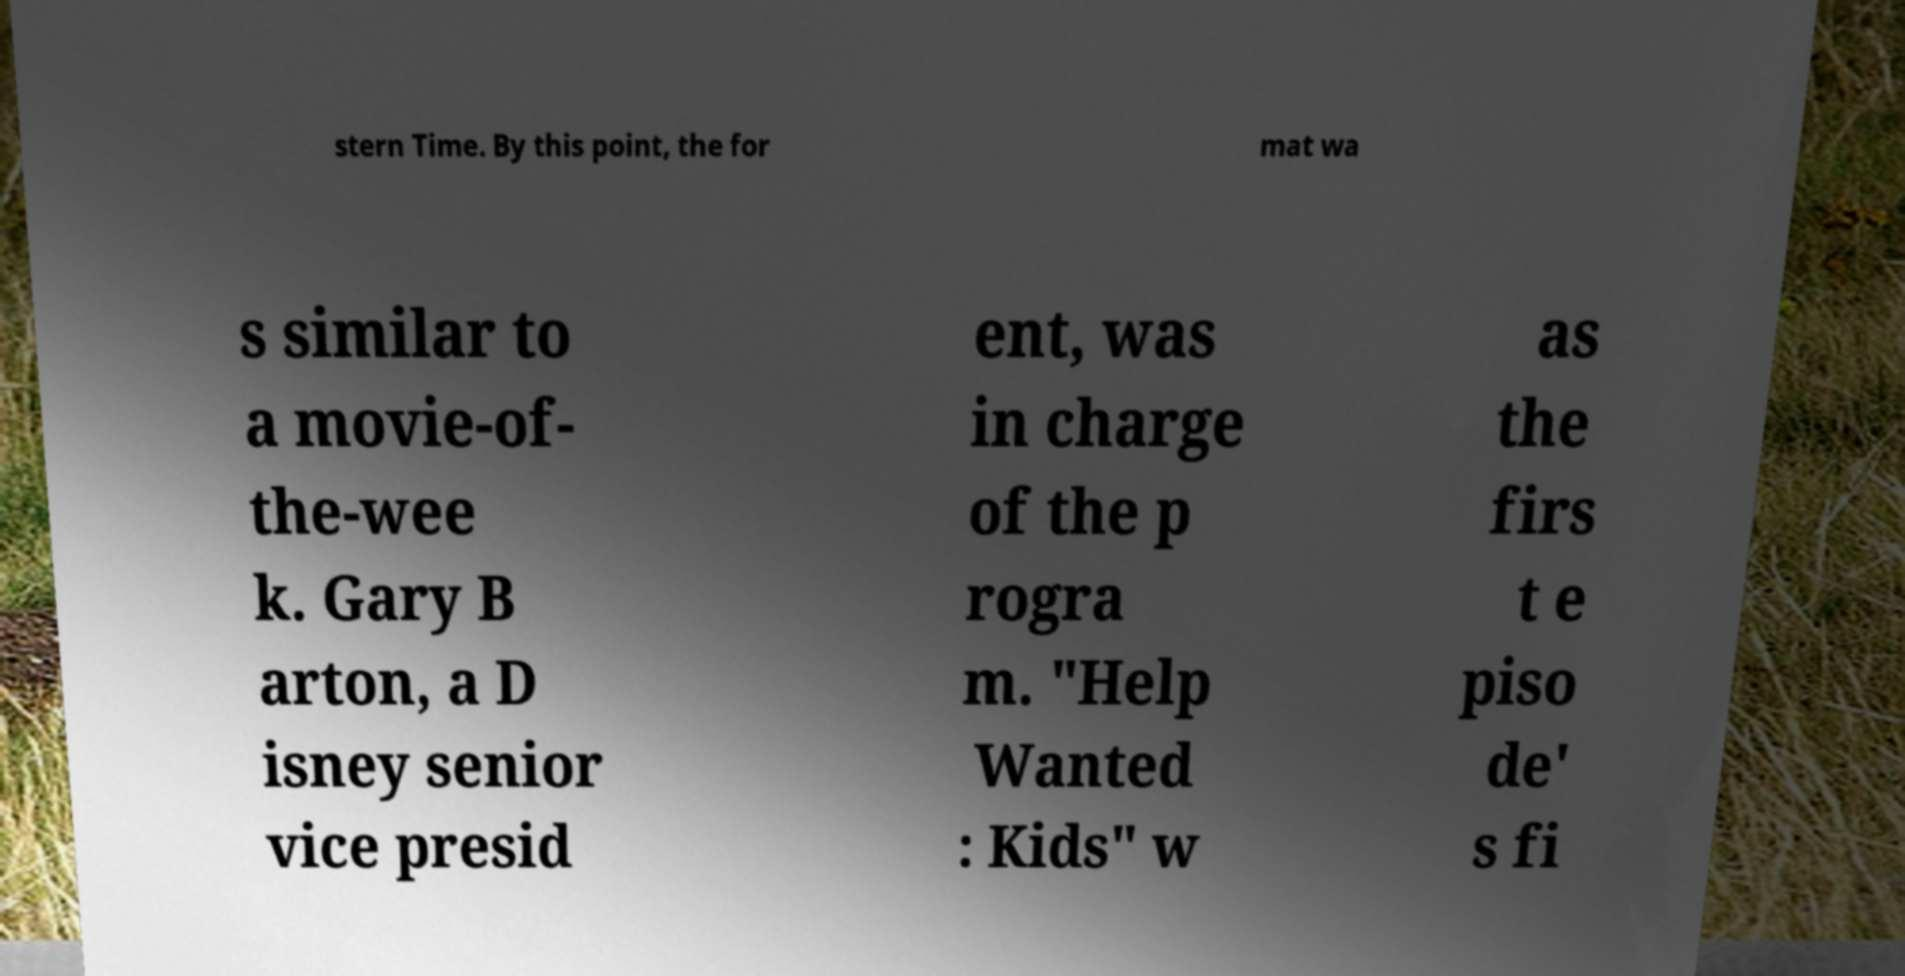Can you accurately transcribe the text from the provided image for me? stern Time. By this point, the for mat wa s similar to a movie-of- the-wee k. Gary B arton, a D isney senior vice presid ent, was in charge of the p rogra m. "Help Wanted : Kids" w as the firs t e piso de' s fi 